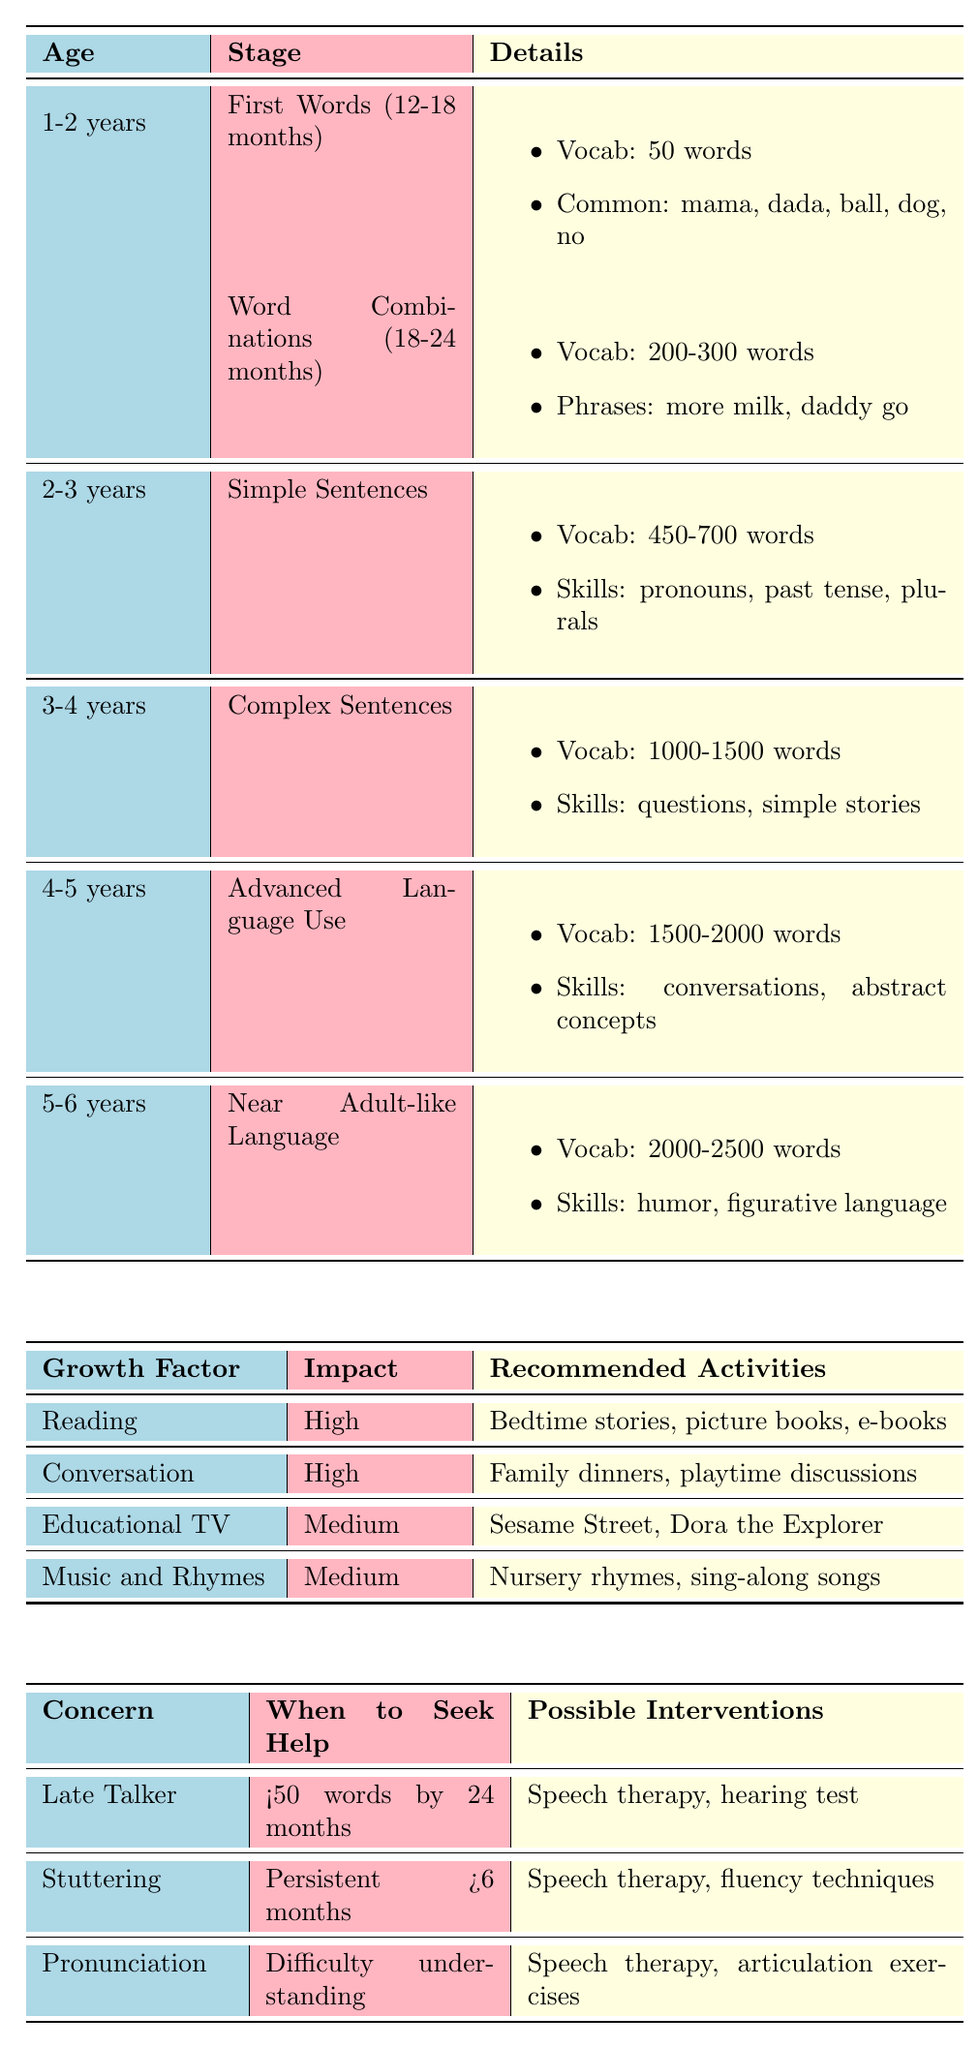What is the typical age range for the "First Words" stage? The "First Words" stage occurs at 12-18 months of age, as stated in the table under the milestones for the 1-2 years age category.
Answer: 12-18 months How many words does a child typically have at 2-3 years according to the table? At 2-3 years, the typical vocabulary size according to the "Simple Sentences" milestone is 450-700 words, as specified in the details for that age group.
Answer: 450-700 words What are the common words for the "First Words" milestone? The common words listed under the "First Words" milestone are mama, dada, ball, dog, and no, which are directly mentioned in the table.
Answer: mama, dada, ball, dog, no Is reading considered a high impact factor for vocabulary growth? Yes, according to the table, reading is categorized as a "High" impact factor for vocabulary growth, which is clearly indicated in the section detailing growth factors.
Answer: Yes At what age should parents be concerned if their child is a "Late Talker"? Parents should be concerned about a "Late Talker" if their child has less than 50 words by 24 months, as mentioned under the common parental concerns in the table.
Answer: 24 months What vocabulary size is associated with "Advanced Language Use"? The "Advanced Language Use" stage at 4-5 years has an associated vocabulary size of 1500-2000 words, as shown in the milestones in the table.
Answer: 1500-2000 words What are two activities recommended to support vocabulary growth through conversation? Two recommended activities to support vocabulary growth through conversation are family dinners and open-ended questions, as listed under the "Conversation" growth factor in the table.
Answer: Family dinners and open-ended questions If a child is persistent in stuttering for more than 6 months, when should parents seek help? Parents should seek help if their child’s stuttering is persistent for more than 6 months, according to the guidelines in the table under the stuttering concern.
Answer: More than 6 months What is the difference in average vocabulary size between "Complex Sentences" and "Advanced Language Use"? The average vocabulary size for "Complex Sentences" is 1000-1500 words, while for "Advanced Language Use" it is 1500-2000 words. Calculating the difference gives us 1500 - 1000 = 500 words as the minimum difference.
Answer: 500 words What language skills are developed at the age of 3-4 years? The language skills developed at the age of 3-4 years include asking questions, telling simple stories, and using adjectives, which are outlined under the "Complex Sentences" milestone in the table.
Answer: Asking questions, telling simple stories, using adjectives 